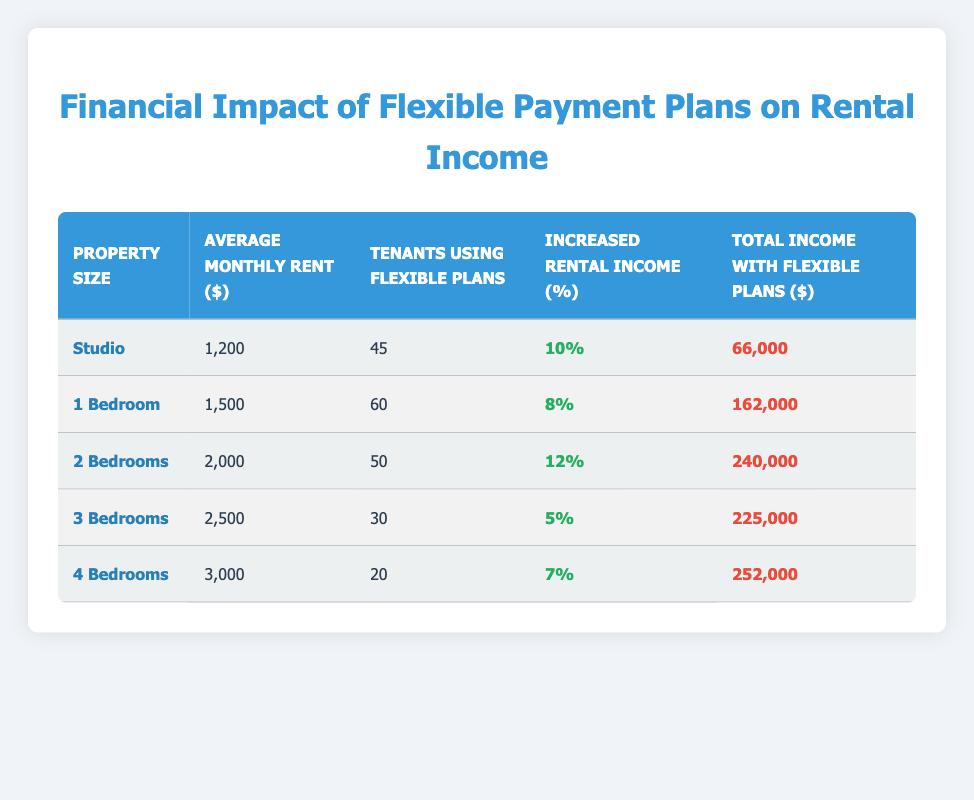What is the average monthly rent for a 2-bedroom property? The table shows that the average monthly rent for a 2-bedroom property is listed as $2000.
Answer: 2000 How many tenants are using flexible payment plans for a studio? The table indicates that 45 tenants are using flexible payment plans for a studio property.
Answer: 45 What is the total income generated from 1-bedroom properties with flexible plans? The total income with flexible plans for 1-bedroom properties is specified as $162000 in the table.
Answer: 162000 Which property size has the highest increased rental income percentage? Reviewing the table, the 2-bedroom property has the highest increased rental income percentage at 12%.
Answer: 12% Is the statement "The total income for 4-bedroom properties is greater than that for 3-bedroom properties" true? The total income for 4-bedroom properties is $252000, while for 3-bedroom properties it is $225000. Since $252000 is greater than $225000, the statement is true.
Answer: Yes What is the percentage difference in increased rental income between studio and 3-bedroom properties? The increased rental income for studios is 10% and for 3-bedroom properties is 5%. The percentage difference is calculated as 10% - 5% = 5%.
Answer: 5% What is the average total rental income across all property sizes listed? The total incomes from all property sizes are: $66000 (studio) + $162000 (1-bedroom) + $240000 (2-bedrooms) + $225000 (3-bedrooms) + $252000 (4-bedrooms) = $1,185,000. Then, dividing this sum by 5 property sizes gives an average of $1,185,000 / 5 = $237,000.
Answer: 237000 How many more tenants are using flexible payment plans for 1-bedroom properties compared to 4-bedroom properties? The table shows that 60 tenants are using flexible plans for 1-bedroom properties and 20 for 4-bedroom properties. Therefore, the difference is 60 - 20 = 40.
Answer: 40 Which property size has the lowest monthly rent? Among the listed property sizes, the studio has the lowest average monthly rent of $1200.
Answer: Studio 